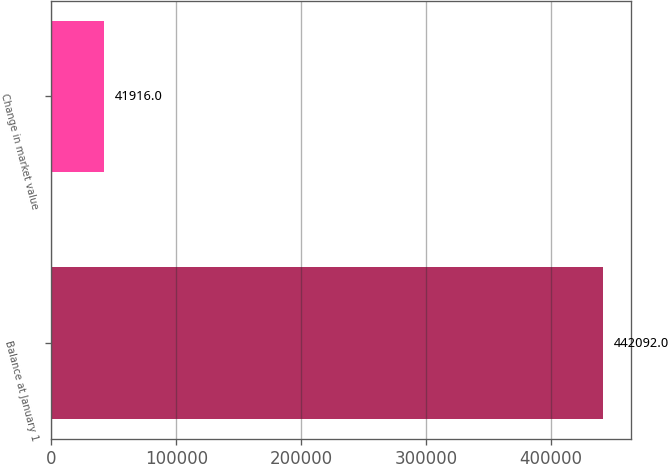<chart> <loc_0><loc_0><loc_500><loc_500><bar_chart><fcel>Balance at January 1<fcel>Change in market value<nl><fcel>442092<fcel>41916<nl></chart> 